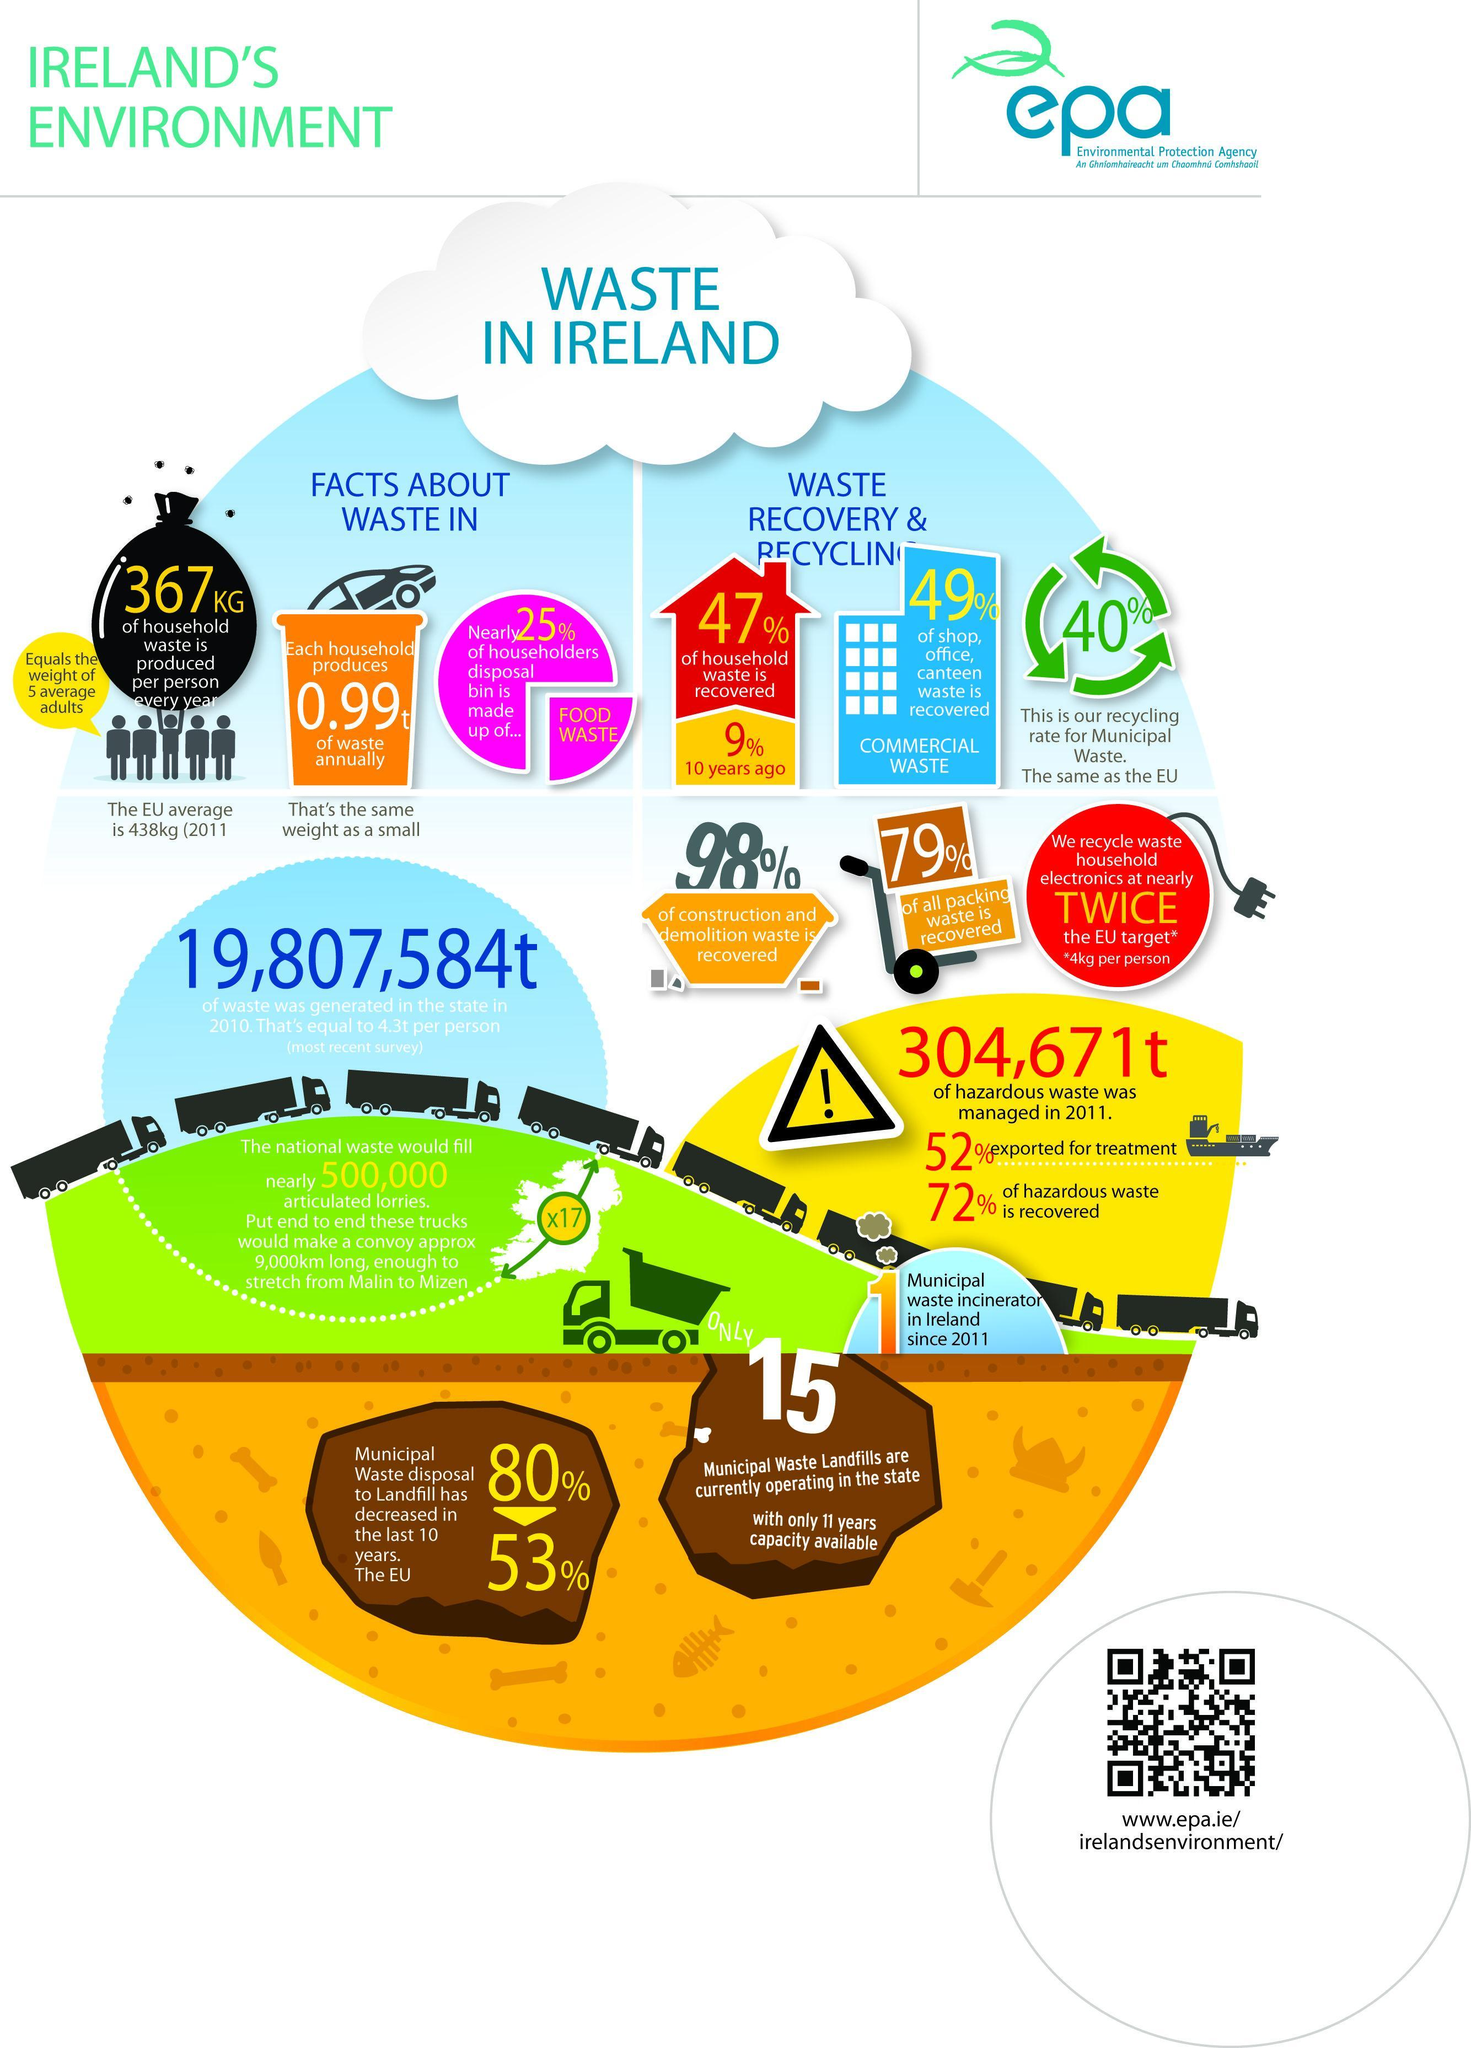What percentage decrease in the Municipal waste disposal to landfill has occurred in Ireland in the last 10 year?
Answer the question with a short phrase. 53% What percentage of commercial waste has been recovered in Ireland? 49% What is the recycling rate for municipal waste in Ireland? 40% What percentage of household waste has been recovered in Ireland? 47% What percentage of construction & demolition waste has been recovered in Ireland? 98% 